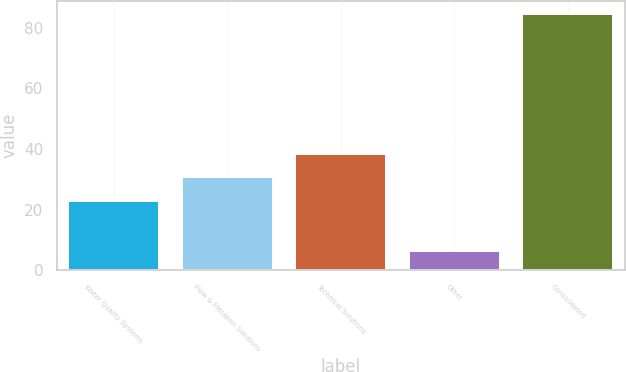Convert chart to OTSL. <chart><loc_0><loc_0><loc_500><loc_500><bar_chart><fcel>Water Quality Systems<fcel>Flow & Filtration Solutions<fcel>Technical Solutions<fcel>Other<fcel>Consolidated<nl><fcel>22.8<fcel>30.64<fcel>38.48<fcel>6.2<fcel>84.6<nl></chart> 